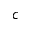<formula> <loc_0><loc_0><loc_500><loc_500>c</formula> 